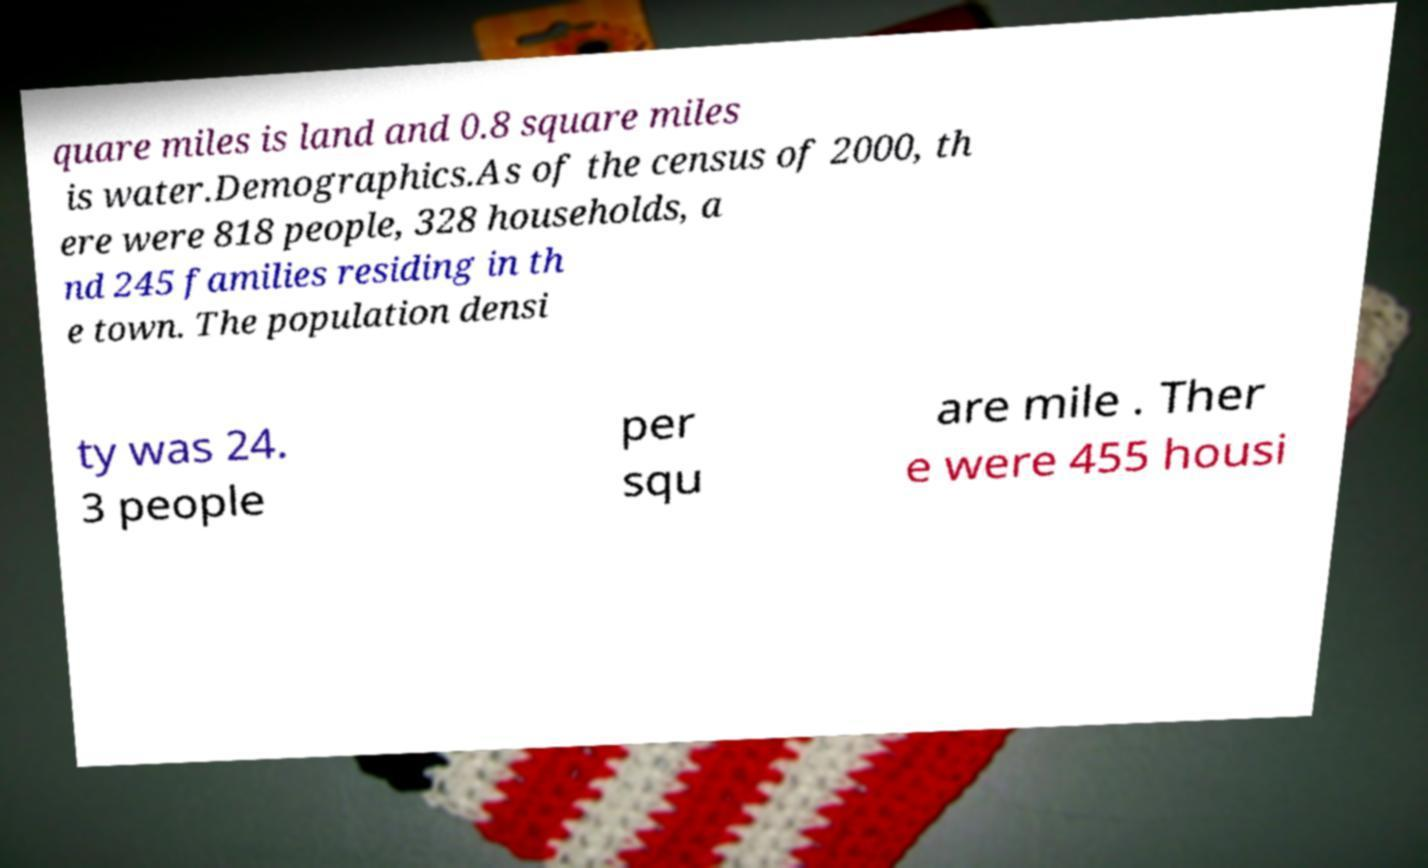Please read and relay the text visible in this image. What does it say? quare miles is land and 0.8 square miles is water.Demographics.As of the census of 2000, th ere were 818 people, 328 households, a nd 245 families residing in th e town. The population densi ty was 24. 3 people per squ are mile . Ther e were 455 housi 